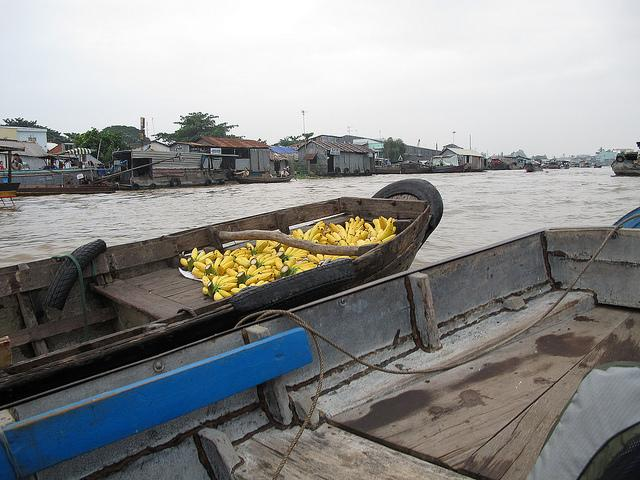What food is on the boat? Please explain your reasoning. banana. You can tell by the color and shape of the fruit as to what is in the boat. 